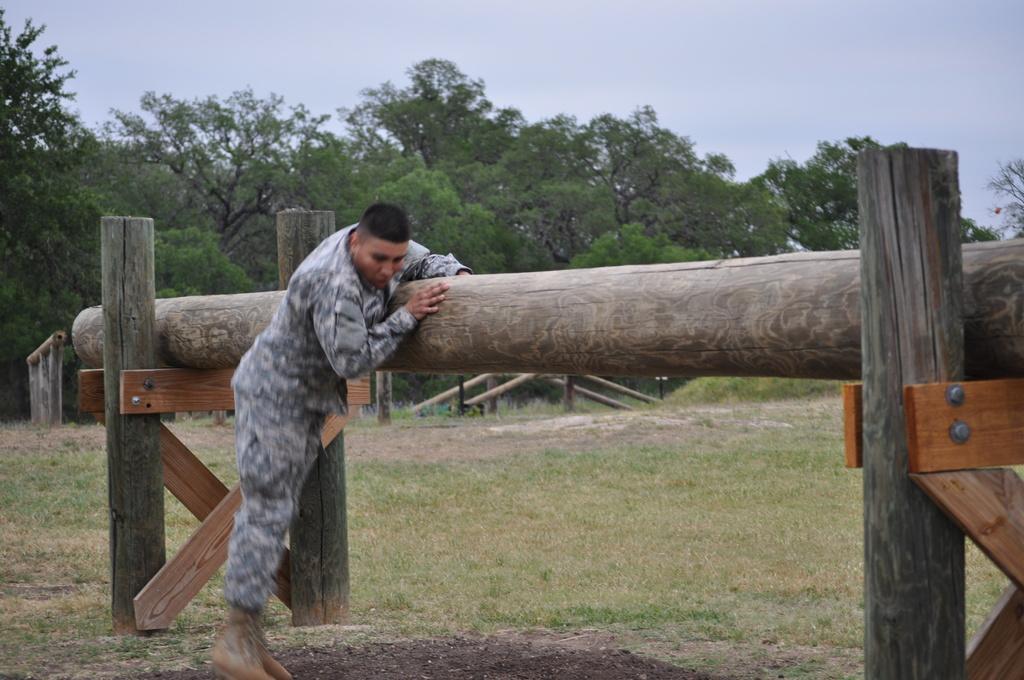Describe this image in one or two sentences. In this image, there is an outside view. There is a person at the bottom of the image wearing clothes. There are some trees in the middle of the image. There is a sky at the top of the image. 